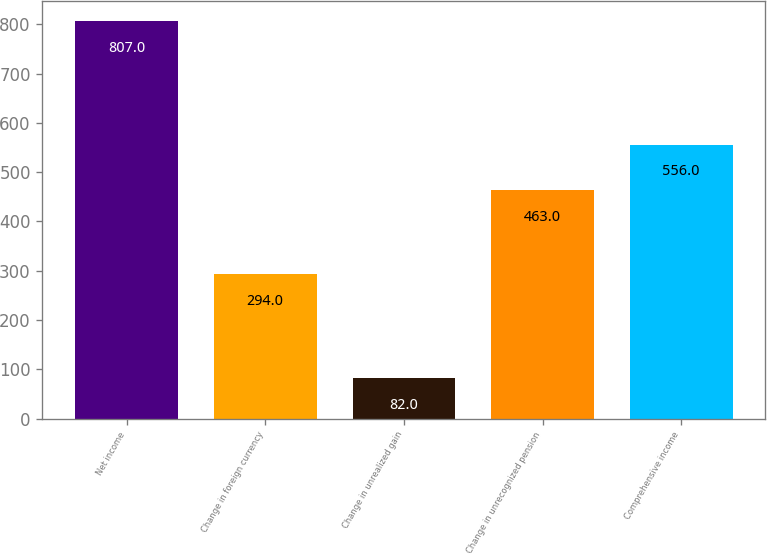Convert chart. <chart><loc_0><loc_0><loc_500><loc_500><bar_chart><fcel>Net income<fcel>Change in foreign currency<fcel>Change in unrealized gain<fcel>Change in unrecognized pension<fcel>Comprehensive income<nl><fcel>807<fcel>294<fcel>82<fcel>463<fcel>556<nl></chart> 